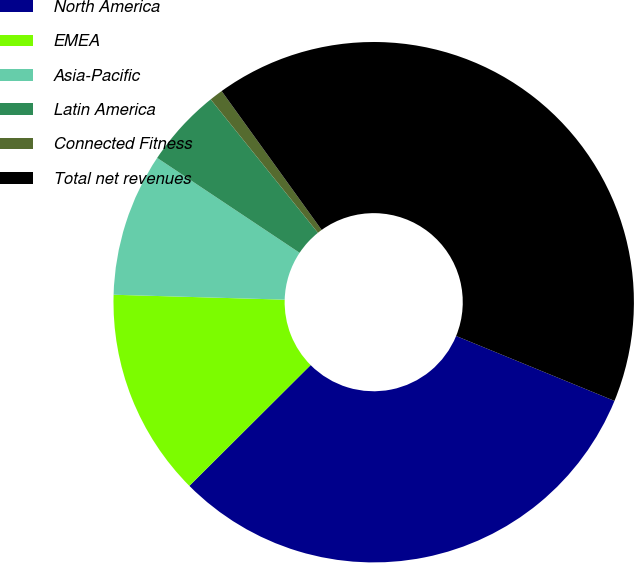<chart> <loc_0><loc_0><loc_500><loc_500><pie_chart><fcel>North America<fcel>EMEA<fcel>Asia-Pacific<fcel>Latin America<fcel>Connected Fitness<fcel>Total net revenues<nl><fcel>31.34%<fcel>12.93%<fcel>8.9%<fcel>4.87%<fcel>0.84%<fcel>41.13%<nl></chart> 